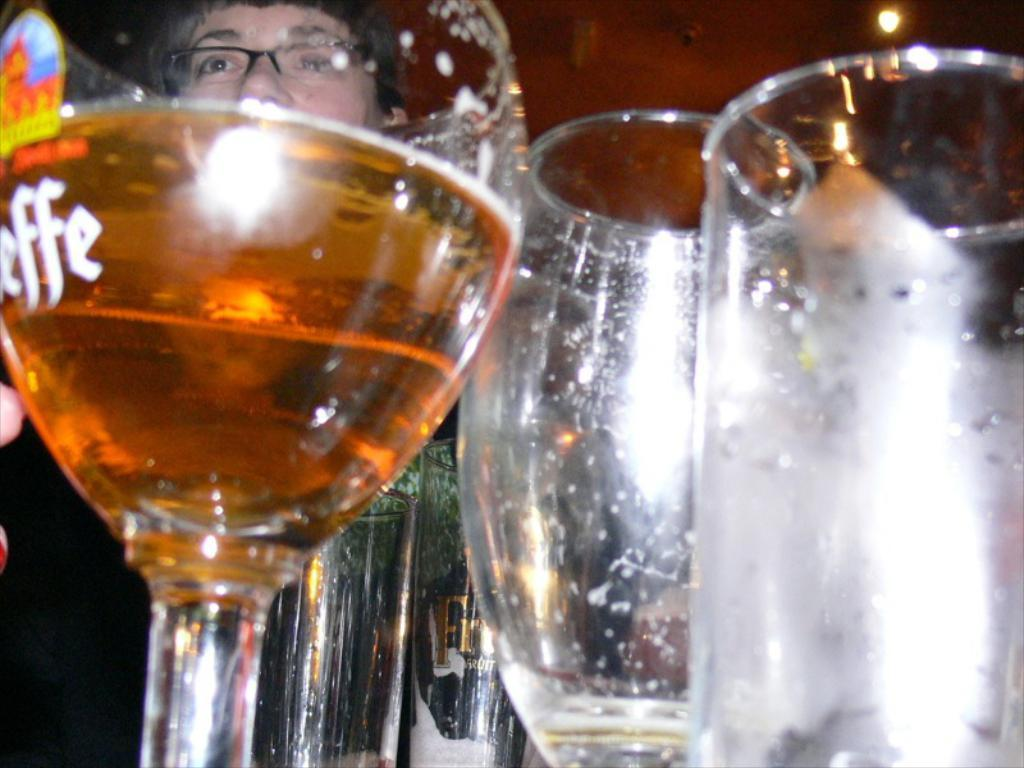What objects are present in the image that are typically used for drinking? There are glasses in the image. What is contained within the glasses in the image? There is a drink in the image. Can you describe the person in the background of the image? There is a person wearing spectacles in the background of the image. What type of letter is being stitched onto the grass in the image? There is no letter or grass present in the image; it only features glasses, a drink, and a person wearing spectacles in the background. 